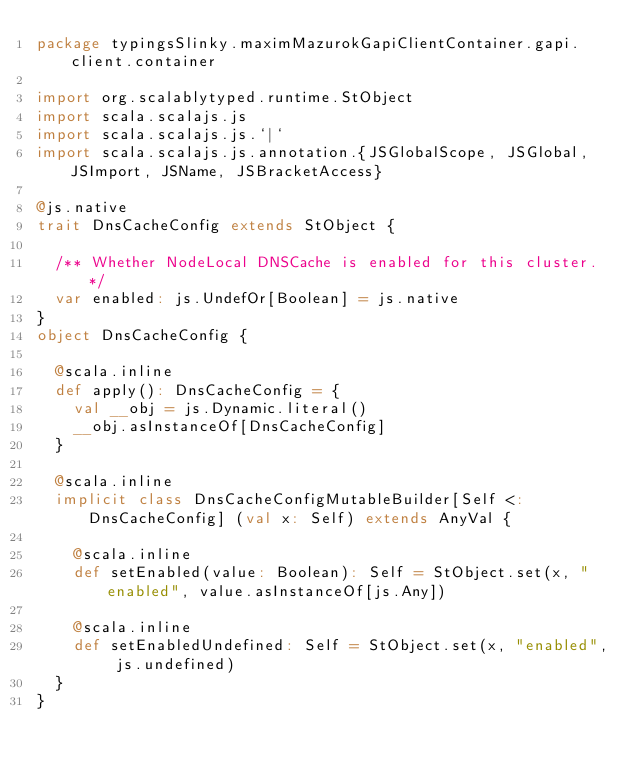Convert code to text. <code><loc_0><loc_0><loc_500><loc_500><_Scala_>package typingsSlinky.maximMazurokGapiClientContainer.gapi.client.container

import org.scalablytyped.runtime.StObject
import scala.scalajs.js
import scala.scalajs.js.`|`
import scala.scalajs.js.annotation.{JSGlobalScope, JSGlobal, JSImport, JSName, JSBracketAccess}

@js.native
trait DnsCacheConfig extends StObject {
  
  /** Whether NodeLocal DNSCache is enabled for this cluster. */
  var enabled: js.UndefOr[Boolean] = js.native
}
object DnsCacheConfig {
  
  @scala.inline
  def apply(): DnsCacheConfig = {
    val __obj = js.Dynamic.literal()
    __obj.asInstanceOf[DnsCacheConfig]
  }
  
  @scala.inline
  implicit class DnsCacheConfigMutableBuilder[Self <: DnsCacheConfig] (val x: Self) extends AnyVal {
    
    @scala.inline
    def setEnabled(value: Boolean): Self = StObject.set(x, "enabled", value.asInstanceOf[js.Any])
    
    @scala.inline
    def setEnabledUndefined: Self = StObject.set(x, "enabled", js.undefined)
  }
}
</code> 